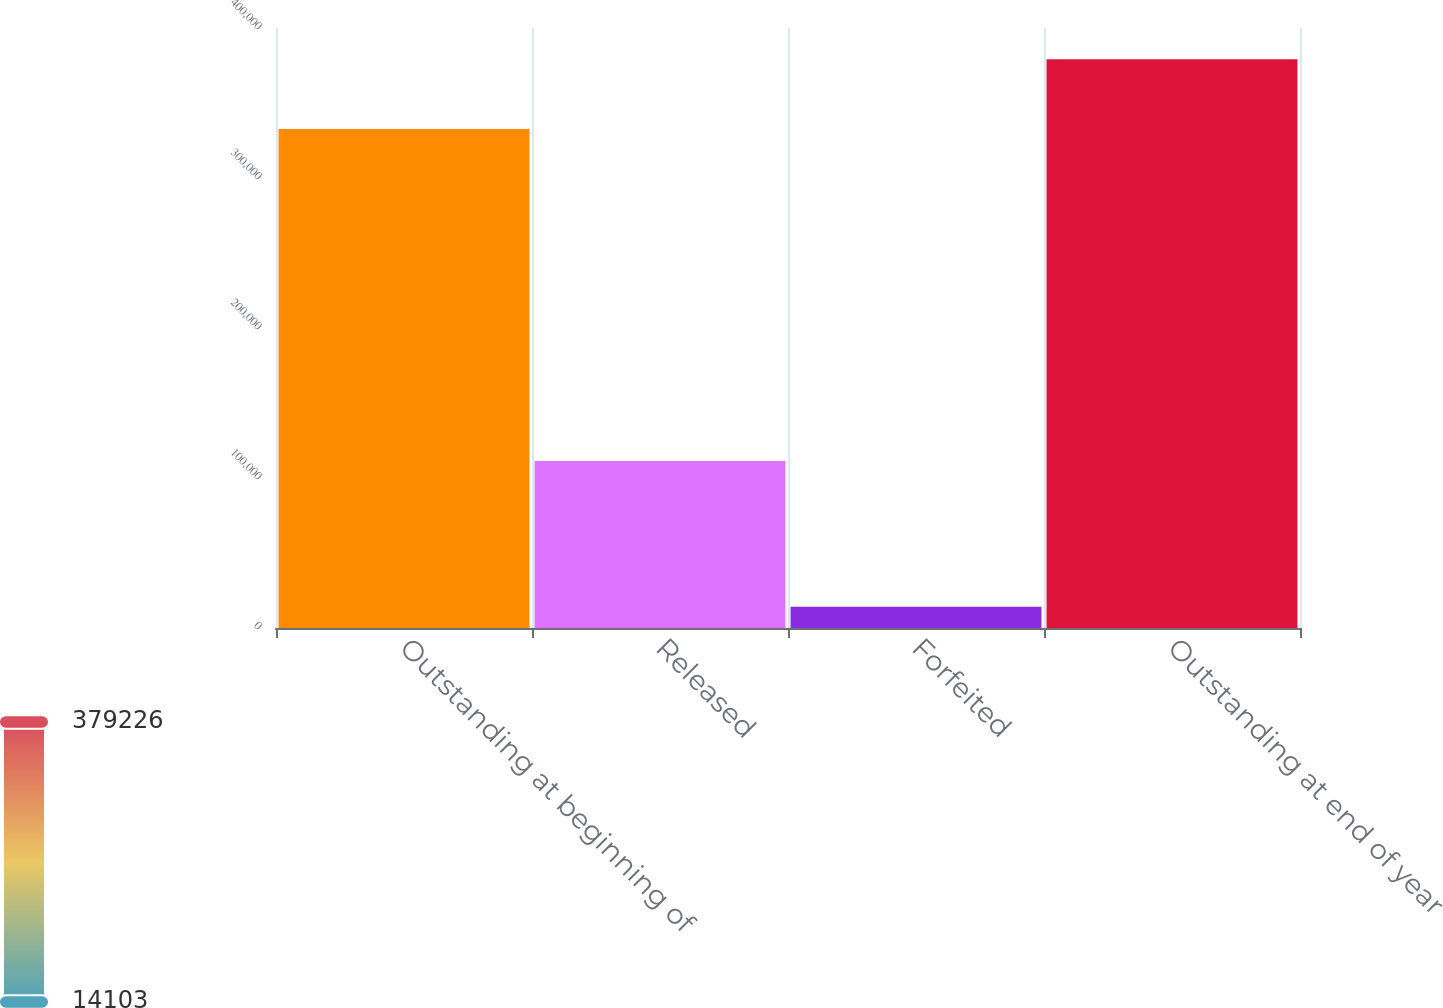<chart> <loc_0><loc_0><loc_500><loc_500><bar_chart><fcel>Outstanding at beginning of<fcel>Released<fcel>Forfeited<fcel>Outstanding at end of year<nl><fcel>332630<fcel>111325<fcel>14103<fcel>379226<nl></chart> 